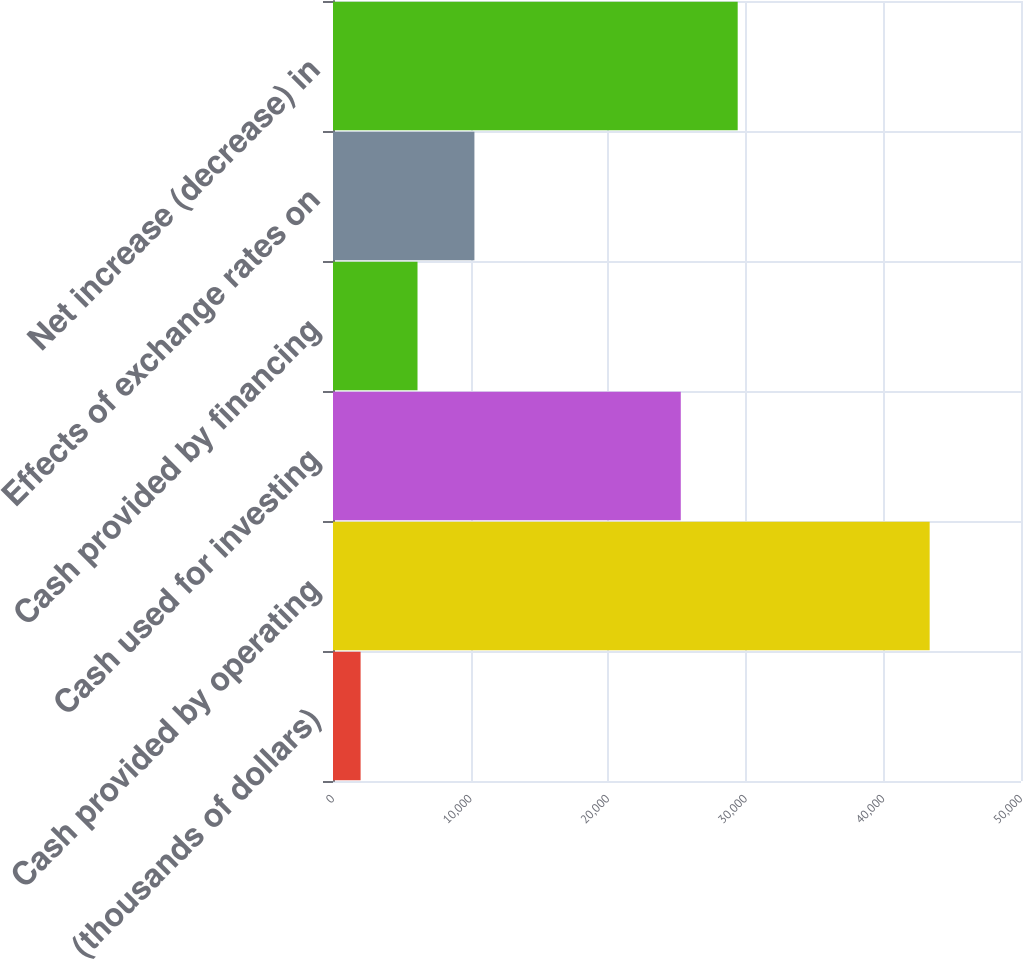<chart> <loc_0><loc_0><loc_500><loc_500><bar_chart><fcel>(thousands of dollars)<fcel>Cash provided by operating<fcel>Cash used for investing<fcel>Cash provided by financing<fcel>Effects of exchange rates on<fcel>Net increase (decrease) in<nl><fcel>2006<fcel>43362<fcel>25275<fcel>6141.6<fcel>10277.2<fcel>29410.6<nl></chart> 